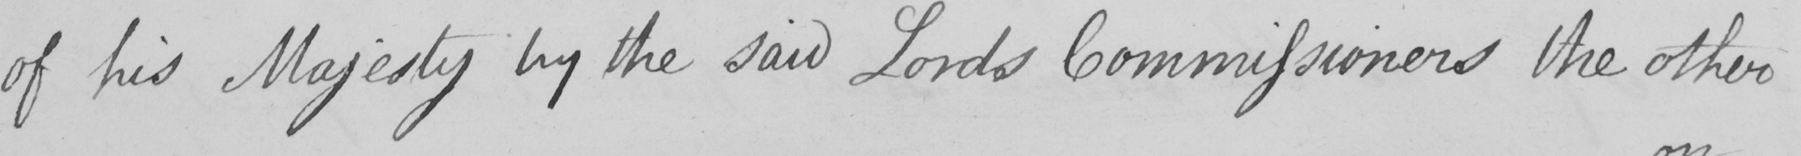What text is written in this handwritten line? of his Majesty by the said Lords Commissioners the other 